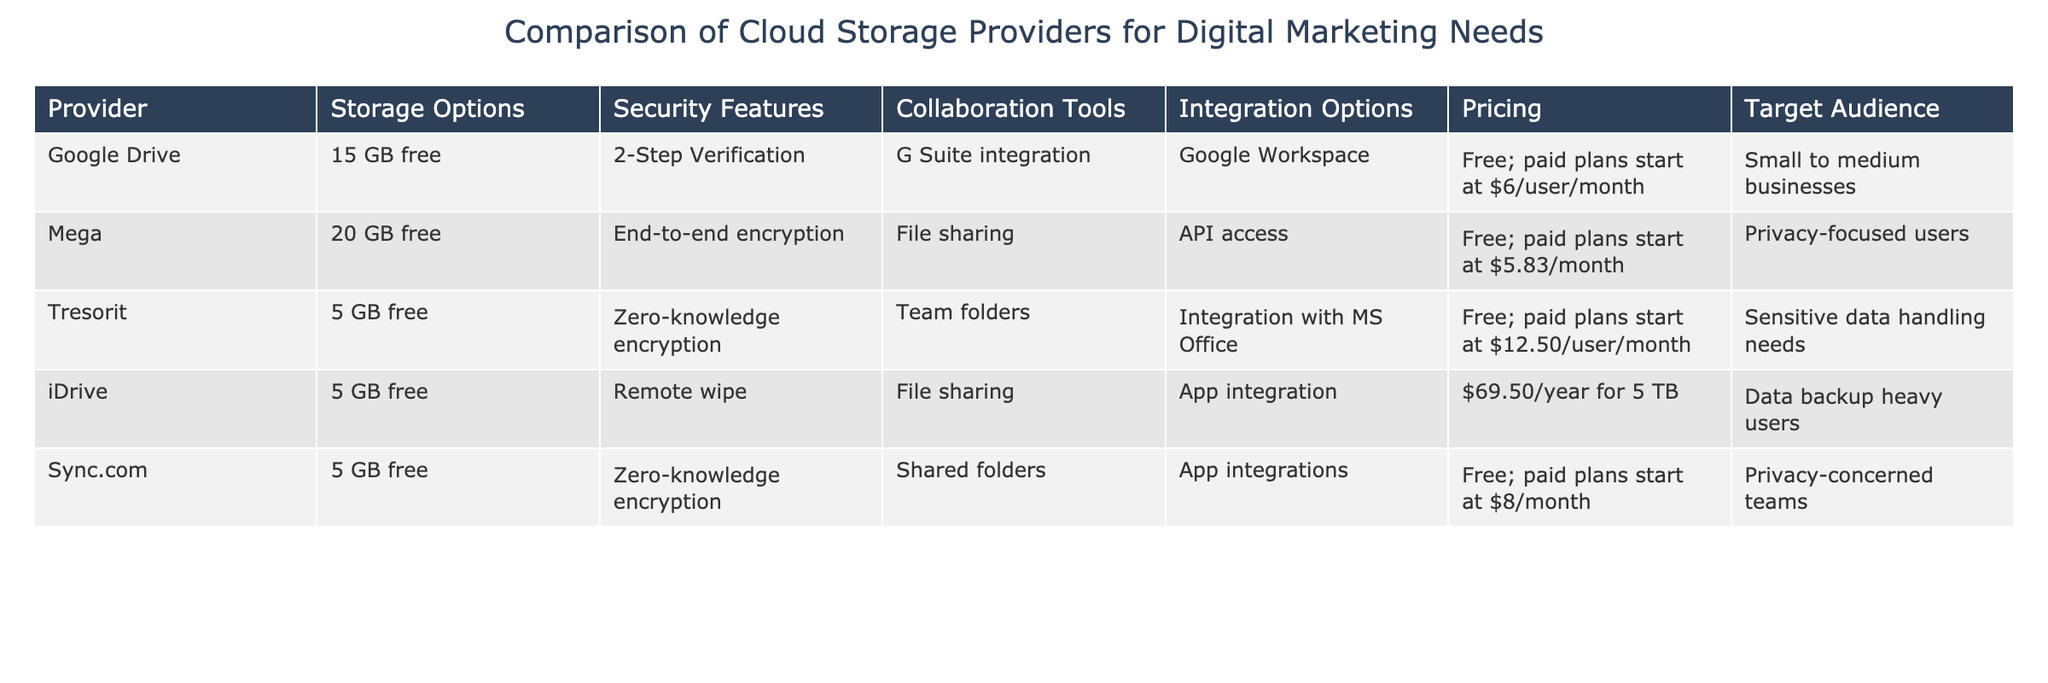What are the storage options provided by Google Drive? The table shows that Google Drive offers 15 GB of free storage. It is the only storage option listed under the storage options column for Google Drive.
Answer: 15 GB free Which provider has end-to-end encryption as a security feature? According to the table, Mega is the provider that specifically mentions end-to-end encryption in its security features.
Answer: Mega How much does Tresorit's paid plan start at? The table indicates that Tresorit's paid plans start at $12.50 per user per month. This information can be found in the pricing column under Tresorit.
Answer: $12.50/user/month Which cloud storage provider is targeted at sensitive data handling needs and what is its free storage option? From the table, Tresorit is the provider that targets sensitive data handling needs, and it offers 5 GB of free storage.
Answer: Tresorit; 5 GB free If a small to medium business were to choose a cloud storage solution with G Suite integration, which provider would they select and how much is the paid plan? The table shows that Google Drive is the provider with G Suite integration, and its paid plans start at $6 per user per month. Therefore, a small to medium business would select Google Drive with the specified pricing.
Answer: Google Drive; $6/user/month Is there a cloud storage provider that integrates with Microsoft Office? The table indicates that Tresorit offers integration with Microsoft Office, confirming that there is at least one provider with this integration.
Answer: Yes Which provider has the highest amount of free storage and what is that amount? By checking the table, Mega has the highest free storage offering at 20 GB, compared to 15 GB for Google Drive and 5 GB for the others.
Answer: 20 GB Calculate the average starting price of the paid plans for providers listed in the table (consider only paid plans that have a defined starting price). The paid plans for Mega, Tresorit, and Sync.com listed are $5.83, $12.50, and $8 respectively. The average is calculated by adding these values (5.83 + 12.50 + 8) = 26.33 and dividing by 3, yielding approximately 8.78.
Answer: $8.78 Which provider is targeted at privacy-focused users and what is their pricing structure? The table reveals that Mega is targeted at privacy-focused users, with a pricing structure that includes a free option and paid plans starting at $5.83 per month.
Answer: Mega; Free; paid plans start at $5.83/month 